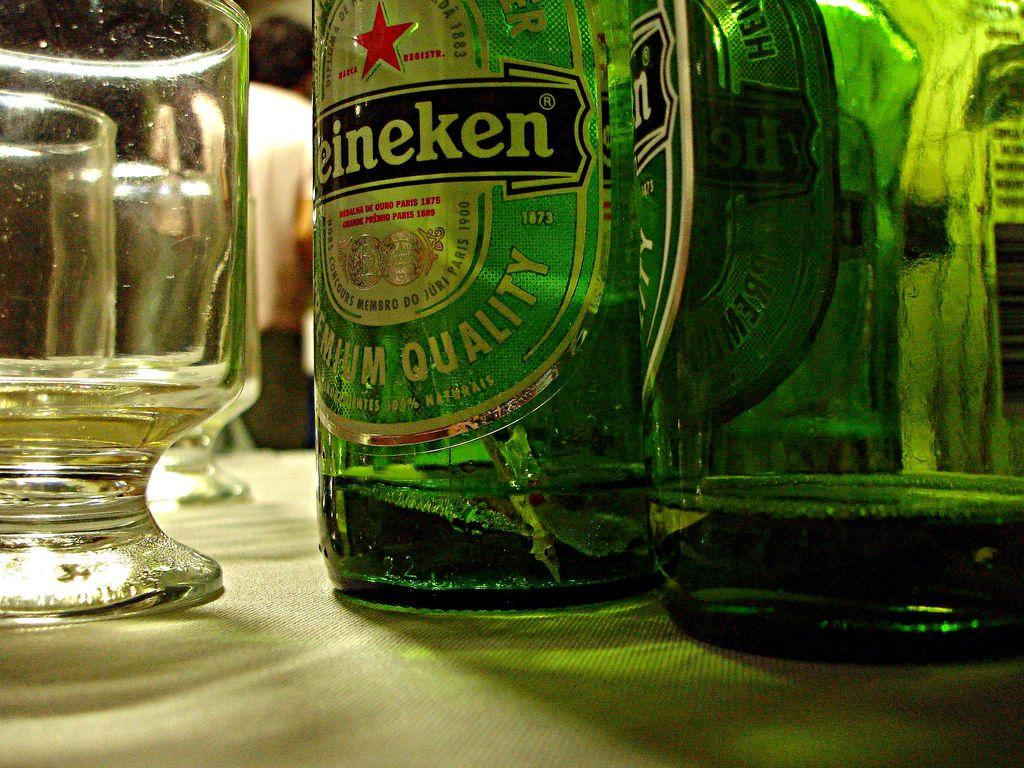<image>
Present a compact description of the photo's key features. Some Heineken beer bottles are at the table. 